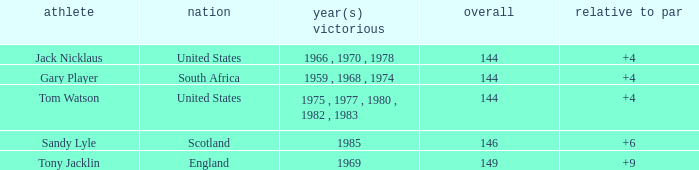What player had a To par smaller than 9 and won in 1985? Sandy Lyle. 